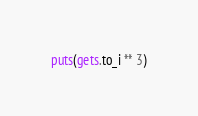Convert code to text. <code><loc_0><loc_0><loc_500><loc_500><_Ruby_>puts(gets.to_i ** 3)</code> 